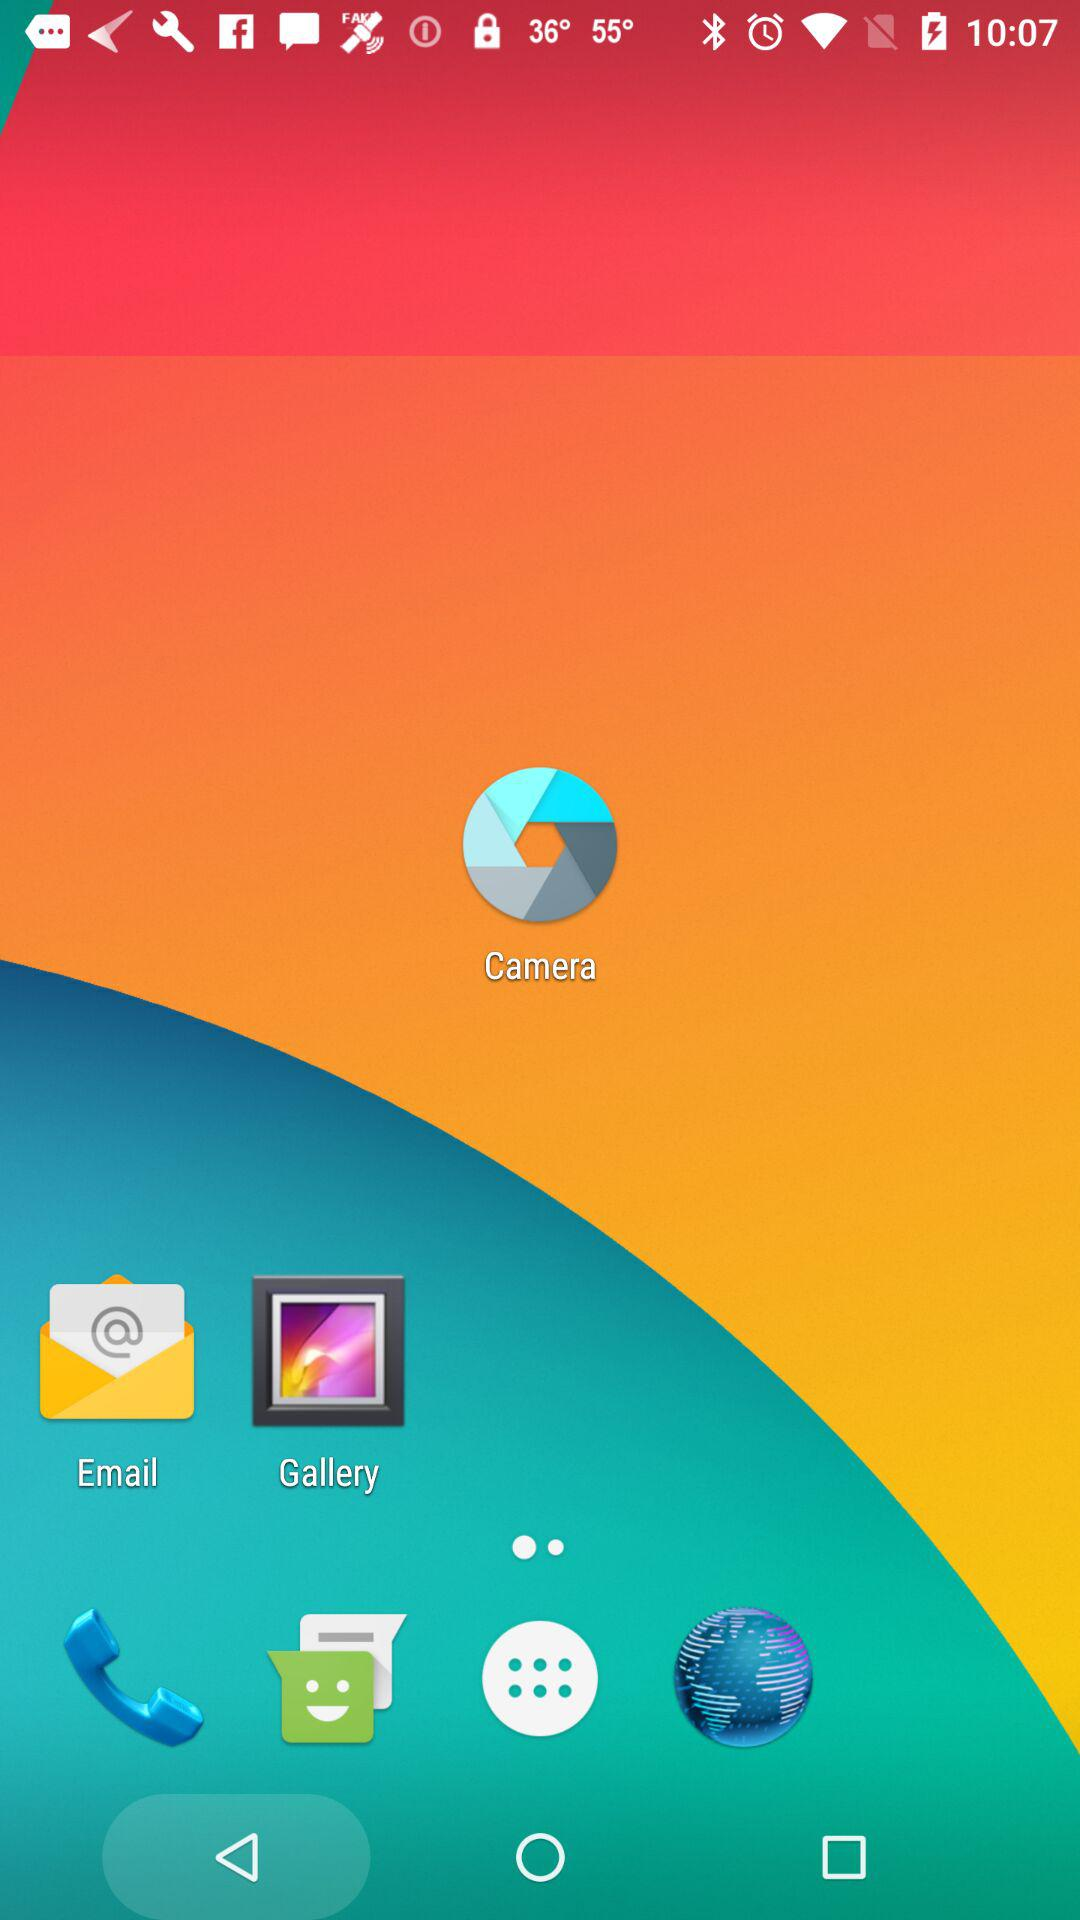For what name is the person searching? The name is "Sam Brown". 